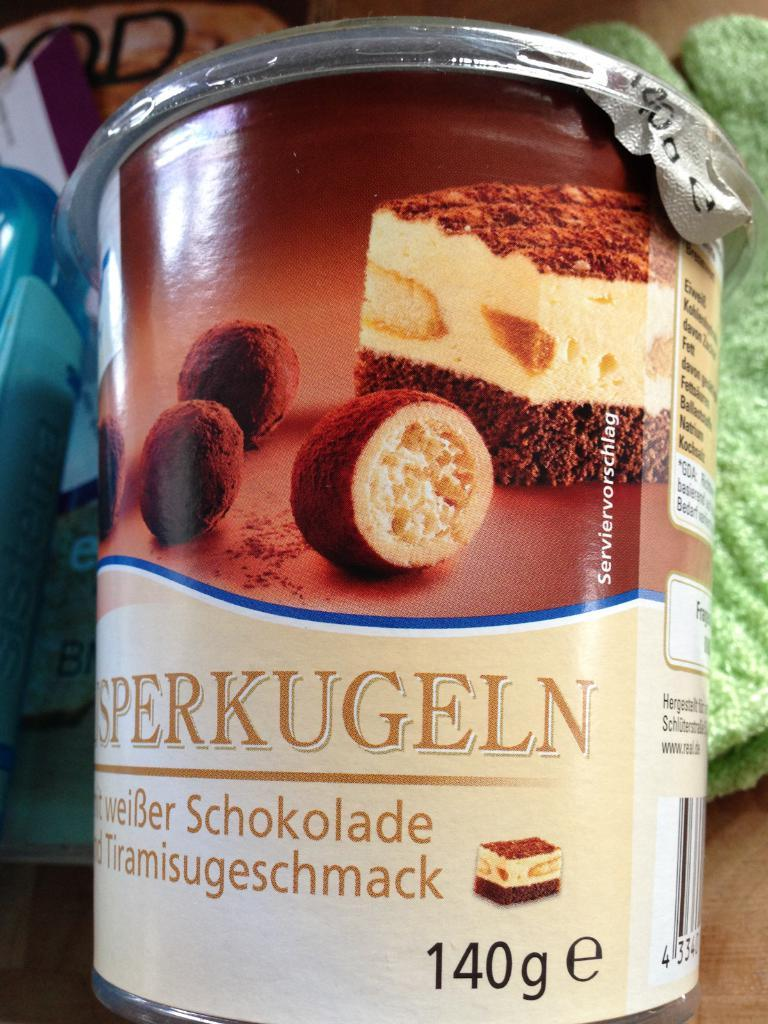What type of surface is visible in the image? There is a floor visible in the image. What kind of container can be seen in the image? There is a food item tin in the image. Can you describe the objects located in the middle of the image? Unfortunately, the facts provided do not specify the nature of the objects in the middle of the image. What type of garden can be seen in the image? There is no garden present in the image. What kind of cracker is being used to play a game with the team in the image? There is no game, team, or cracker present in the image. 